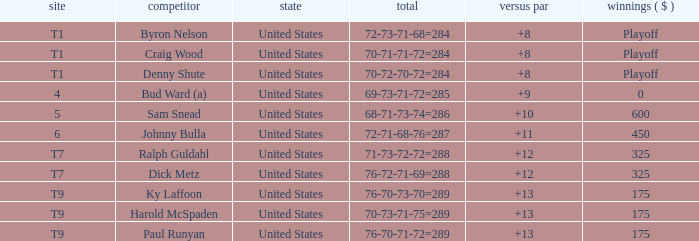What was the score for t9 place for Harold Mcspaden? 70-73-71-75=289. 